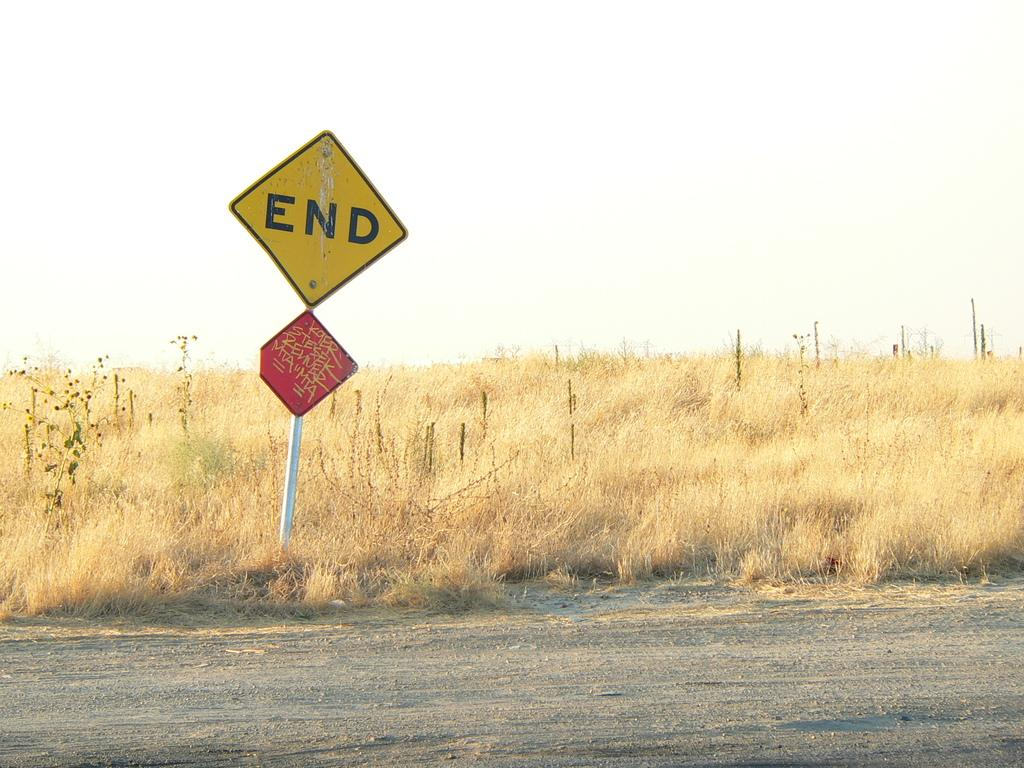<image>
Relay a brief, clear account of the picture shown. the sign that says end on the top of it 